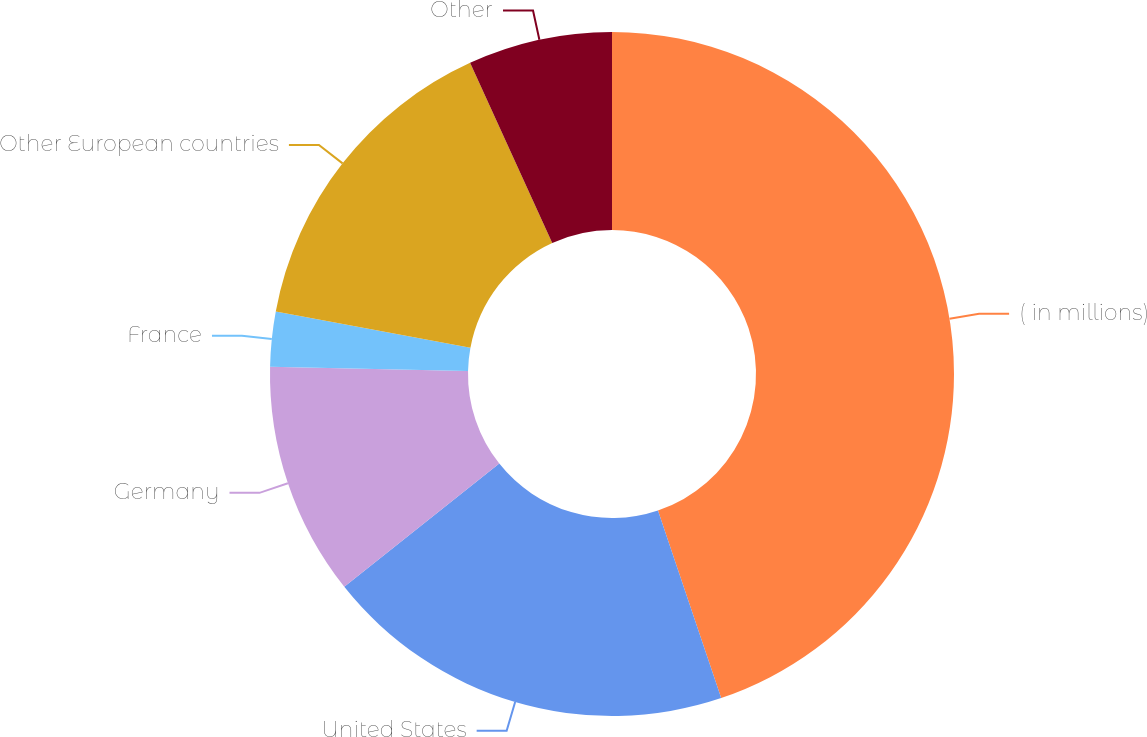Convert chart. <chart><loc_0><loc_0><loc_500><loc_500><pie_chart><fcel>( in millions)<fcel>United States<fcel>Germany<fcel>France<fcel>Other European countries<fcel>Other<nl><fcel>44.83%<fcel>19.48%<fcel>11.03%<fcel>2.59%<fcel>15.26%<fcel>6.81%<nl></chart> 